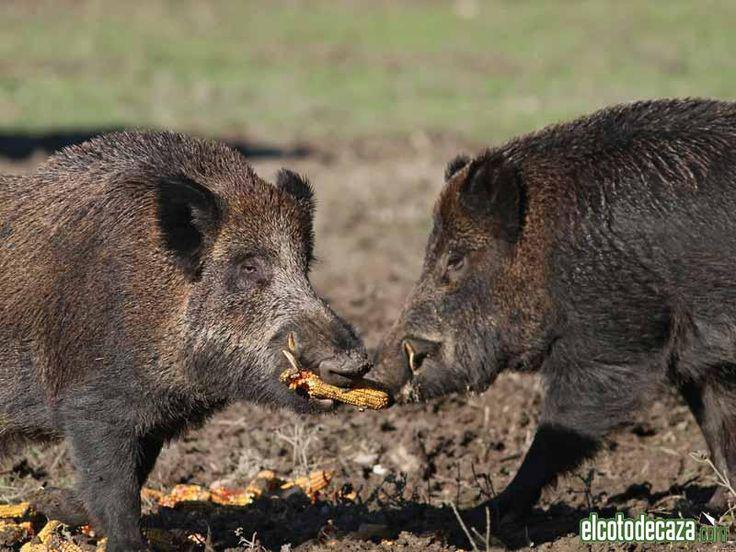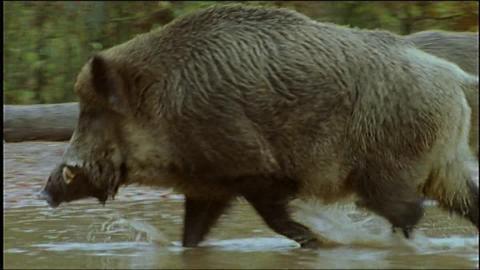The first image is the image on the left, the second image is the image on the right. For the images displayed, is the sentence "The left and right image contains the same number of fighting hogs." factually correct? Answer yes or no. No. The first image is the image on the left, the second image is the image on the right. Considering the images on both sides, is "Each image shows two hogs in a face-to-face confrontation, and in one image the hogs have their front feet off the ground." valid? Answer yes or no. No. 